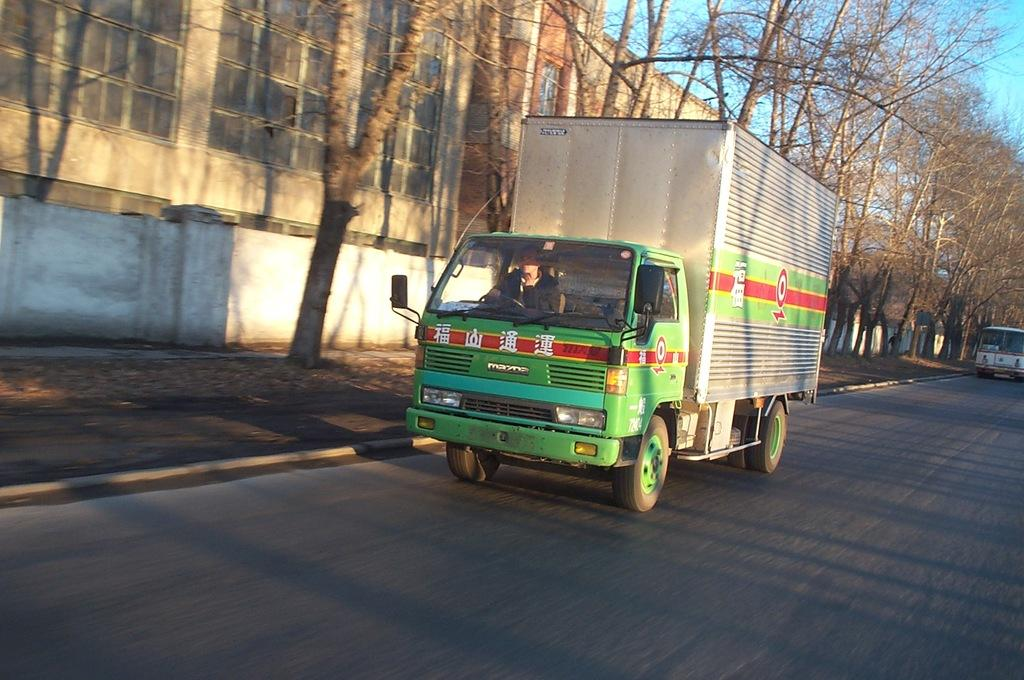What is the main subject of the image? The main subject of the image is a truck. Where is the truck located in the image? The truck is on the road in the image. What can be seen in the background of the image? There are trees and a building visible in the background of the image. What part of the sky can be seen in the image? The sky is partially visible in the image. What type of creature is learning to sing in the image? There is no creature present in the image, and no one is learning to sing. 